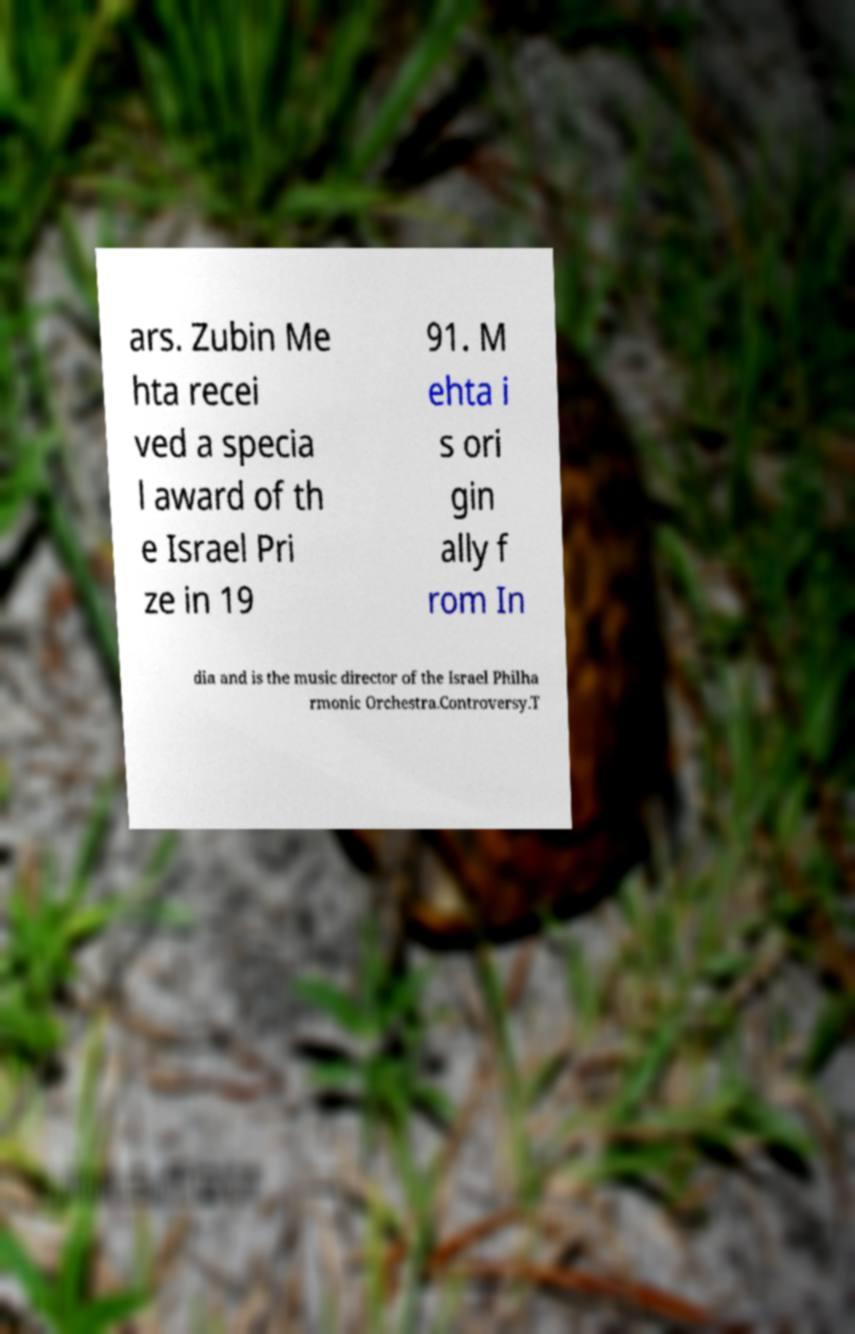Could you extract and type out the text from this image? ars. Zubin Me hta recei ved a specia l award of th e Israel Pri ze in 19 91. M ehta i s ori gin ally f rom In dia and is the music director of the Israel Philha rmonic Orchestra.Controversy.T 